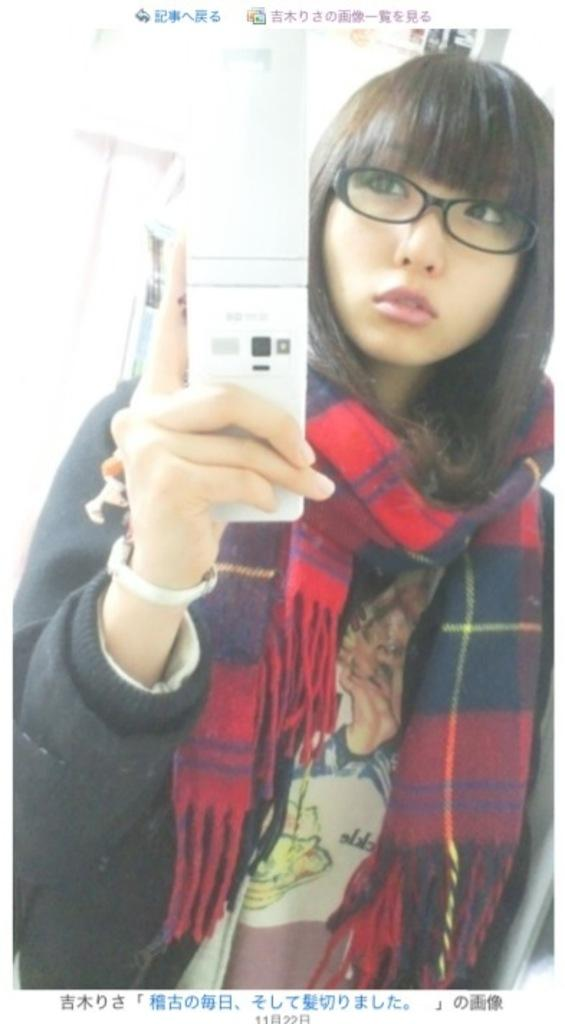Who is present in the image? There is a woman in the image. What is the woman wearing around her neck? The woman is wearing a scarf. What accessory is the woman wearing on her face? The woman is wearing spectacles. What is the woman holding in her hand? The woman is holding a device in her hand. What can be seen at the bottom of the image? There is text at the bottom of the image. What direction is the farm facing in the image? There is no farm present in the image, so it is not possible to determine the direction it might be facing. 